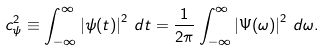Convert formula to latex. <formula><loc_0><loc_0><loc_500><loc_500>c _ { \psi } ^ { 2 } \equiv \int _ { - \infty } ^ { \infty } \left | \psi ( t ) \right | ^ { 2 } \, d t = \frac { 1 } { 2 \pi } \int _ { - \infty } ^ { \infty } \left | \Psi ( \omega ) \right | ^ { 2 } \, d \omega .</formula> 